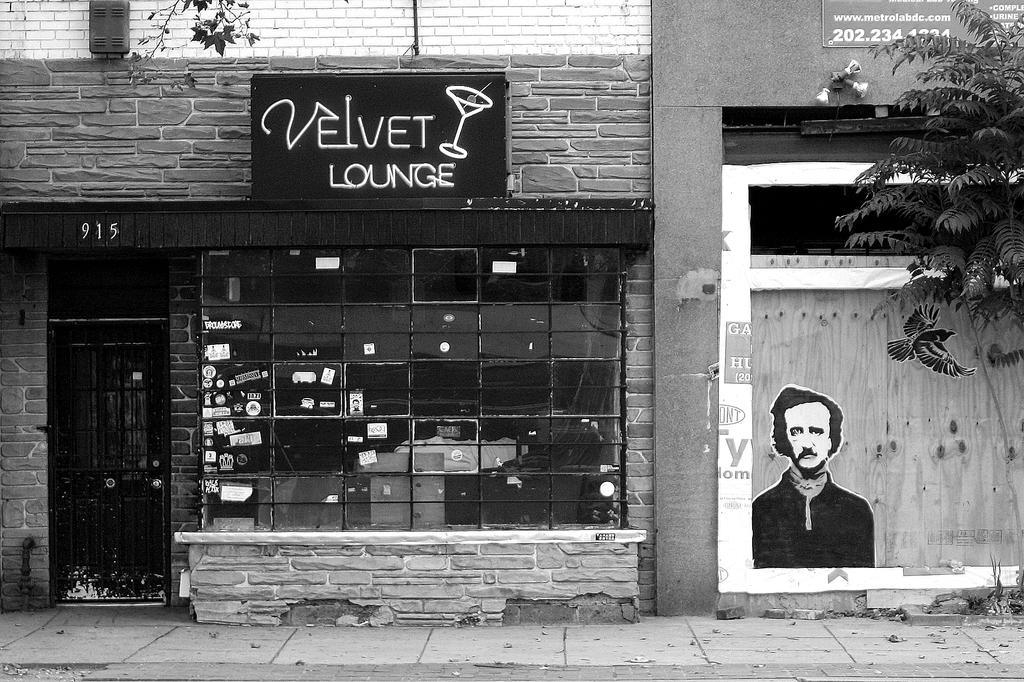Describe this image in one or two sentences. As we can see in the image there are buildings, poster, gate, window and tree. 